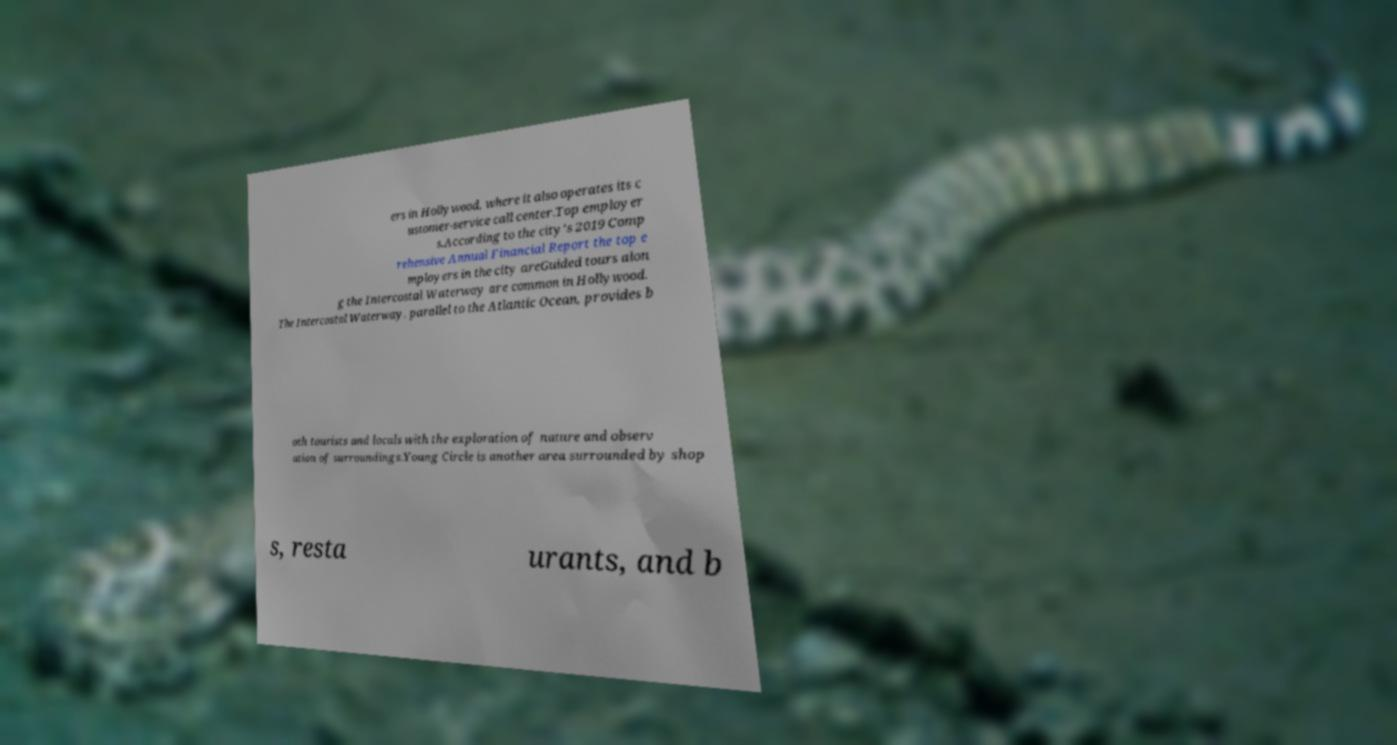I need the written content from this picture converted into text. Can you do that? ers in Hollywood, where it also operates its c ustomer-service call center.Top employer s.According to the city's 2019 Comp rehensive Annual Financial Report the top e mployers in the city areGuided tours alon g the Intercostal Waterway are common in Hollywood. The Intercostal Waterway, parallel to the Atlantic Ocean, provides b oth tourists and locals with the exploration of nature and observ ation of surroundings.Young Circle is another area surrounded by shop s, resta urants, and b 